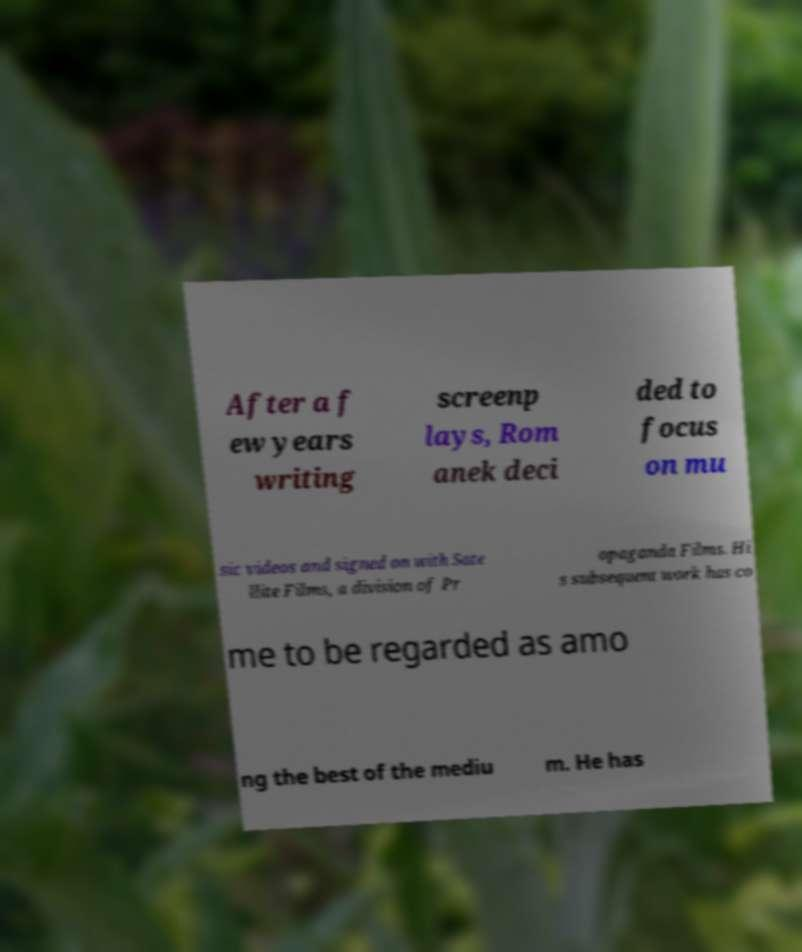Please read and relay the text visible in this image. What does it say? After a f ew years writing screenp lays, Rom anek deci ded to focus on mu sic videos and signed on with Sate llite Films, a division of Pr opaganda Films. Hi s subsequent work has co me to be regarded as amo ng the best of the mediu m. He has 